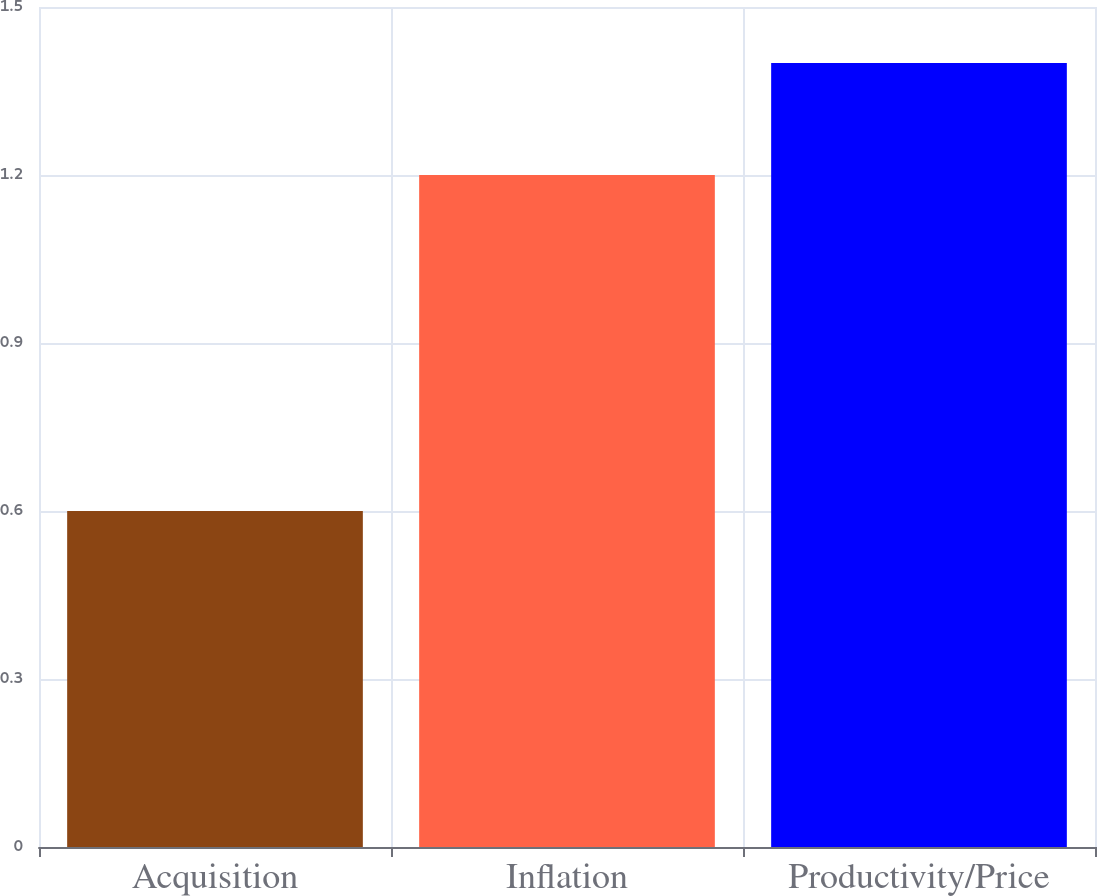Convert chart. <chart><loc_0><loc_0><loc_500><loc_500><bar_chart><fcel>Acquisition<fcel>Inflation<fcel>Productivity/Price<nl><fcel>0.6<fcel>1.2<fcel>1.4<nl></chart> 